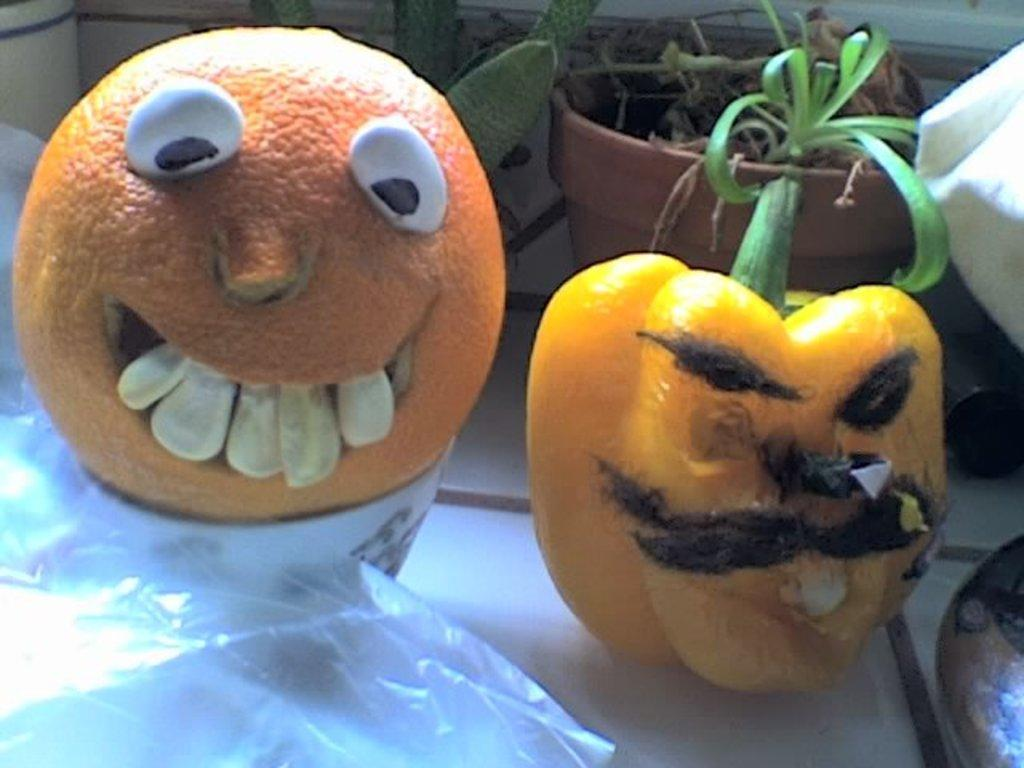What type of vegetable is present in the image? There is a capsicum in the image. What type of fruit is present in the image? There is an orange in the image. What type of containers are visible in the image? There are flower pots in the image. What type of stick can be seen in the image? There is no stick present in the image. What type of ray is visible in the image? There is no ray present in the image. 